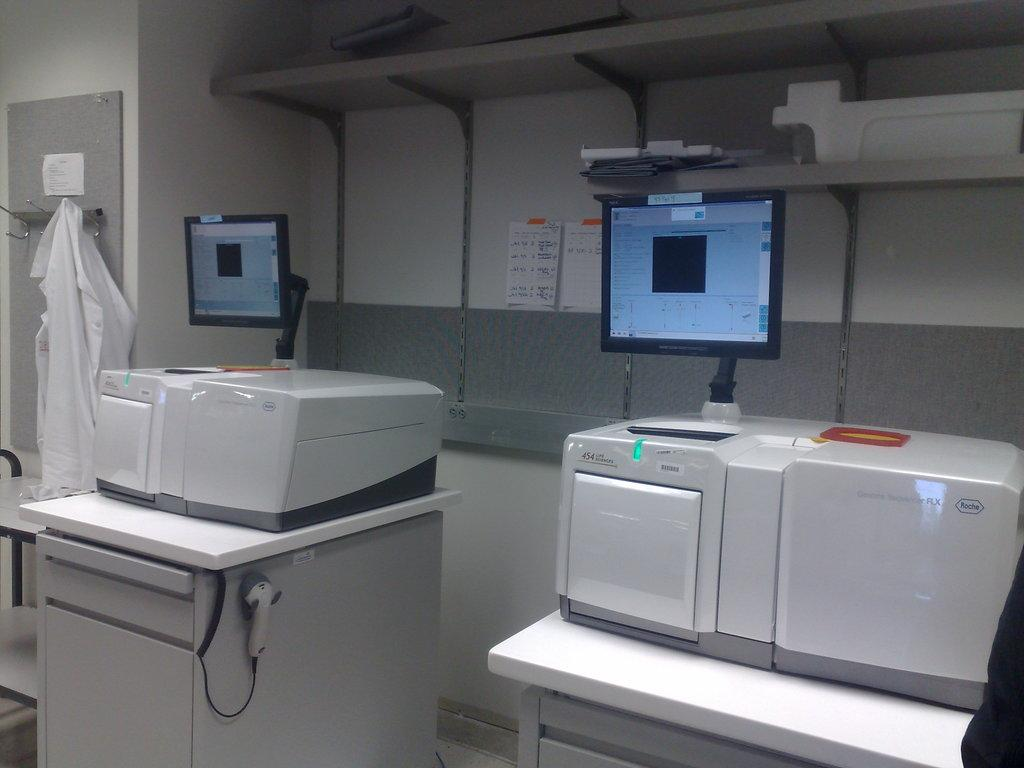What is the main object in the image? There is an equipment in the image. What feature does the equipment have? The equipment has two screens. What can be seen on the right side of the image? There is an apron on the right side of the image. What is visible in the background of the image? There is a wall in the background of the image. What type of powder is being used to create the invention in the image? There is no invention or powder present in the image; it features equipment with two screens and an apron. 